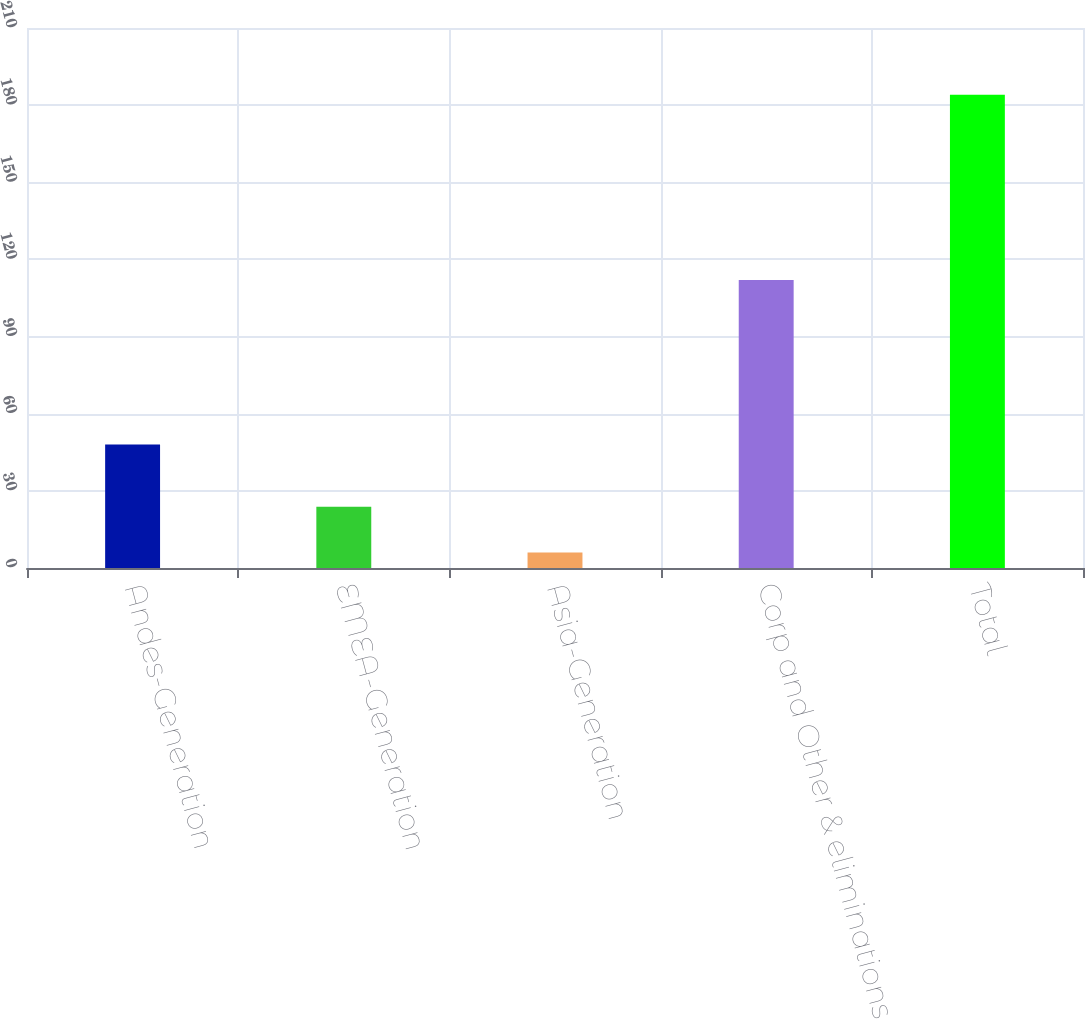<chart> <loc_0><loc_0><loc_500><loc_500><bar_chart><fcel>Andes-Generation<fcel>EMEA-Generation<fcel>Asia-Generation<fcel>Corp and Other & eliminations<fcel>Total<nl><fcel>48<fcel>23.8<fcel>6<fcel>112<fcel>184<nl></chart> 